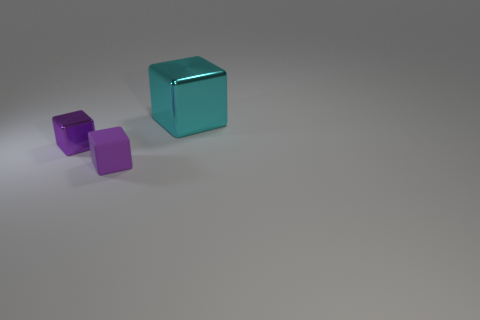Subtract all shiny blocks. How many blocks are left? 1 Add 2 small purple rubber blocks. How many objects exist? 5 Subtract all blue spheres. How many purple blocks are left? 2 Subtract all purple cubes. How many cubes are left? 1 Add 3 tiny green spheres. How many tiny green spheres exist? 3 Subtract 0 purple cylinders. How many objects are left? 3 Subtract all purple cubes. Subtract all green balls. How many cubes are left? 1 Subtract all purple metallic cubes. Subtract all rubber things. How many objects are left? 1 Add 2 purple cubes. How many purple cubes are left? 4 